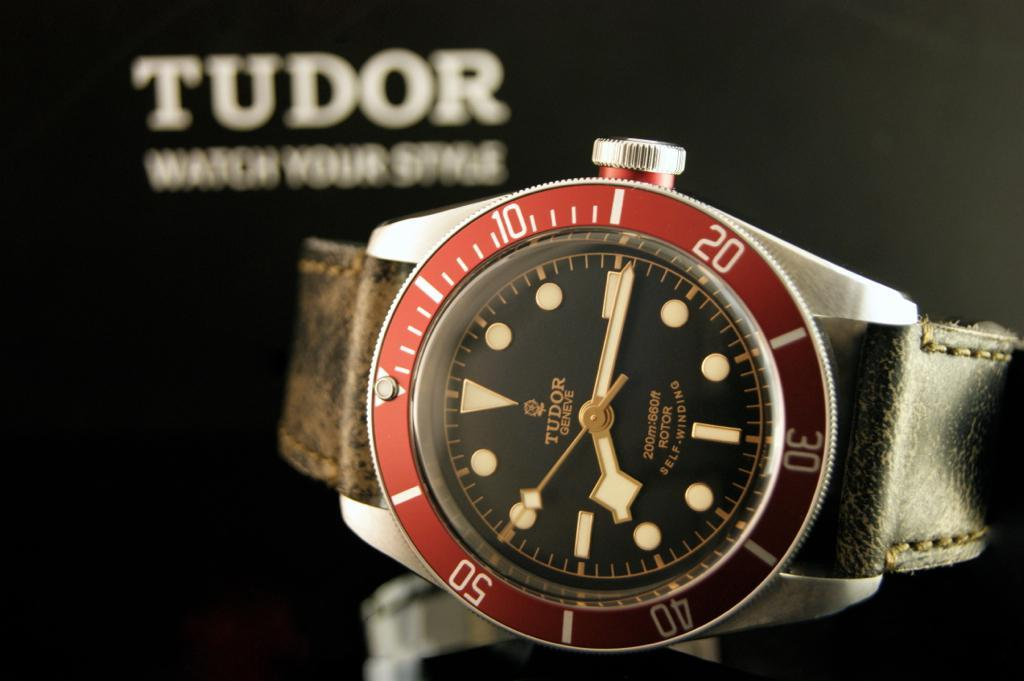<image>
Create a compact narrative representing the image presented. A black and red Tudor brand watch that is self winding. 